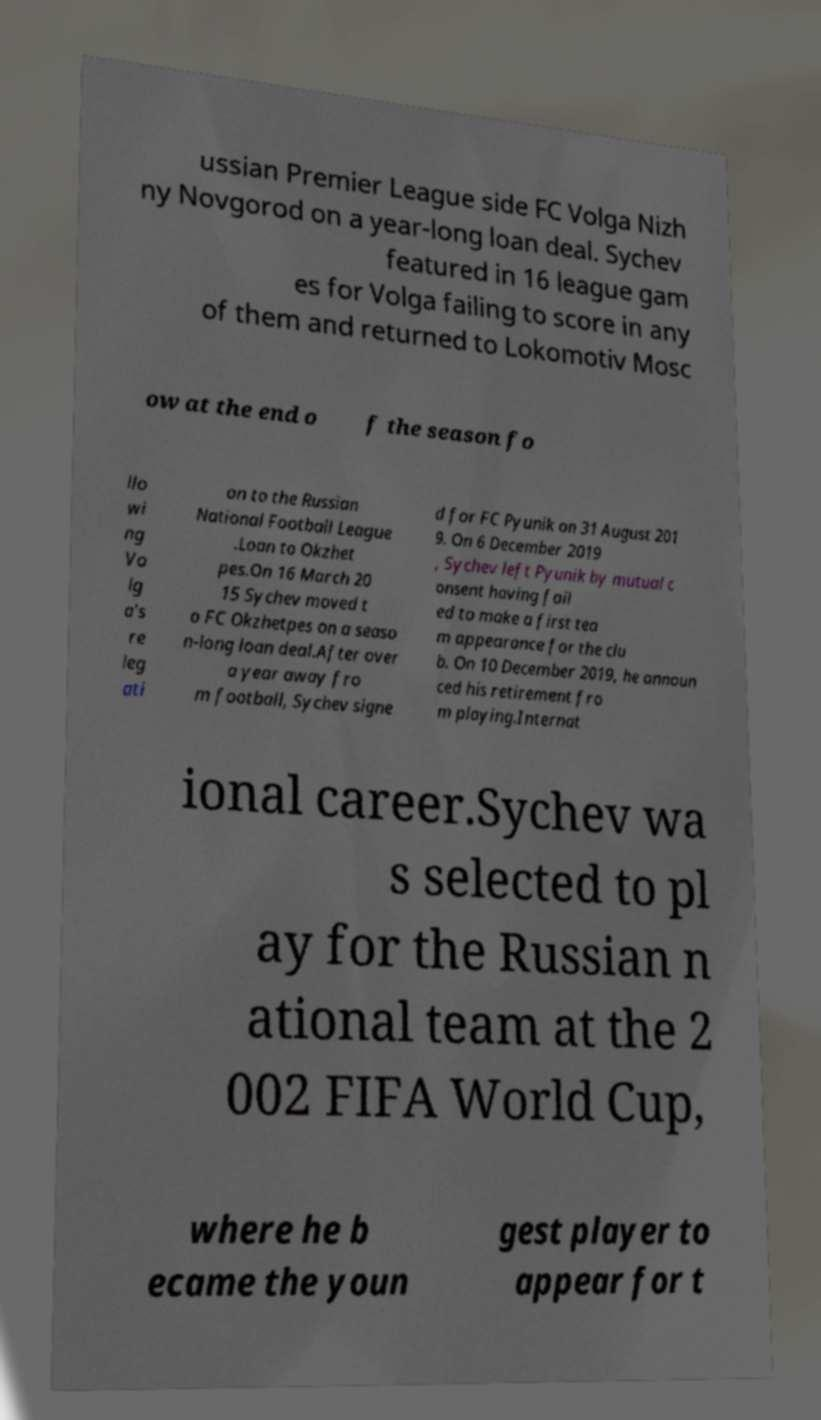Please read and relay the text visible in this image. What does it say? ussian Premier League side FC Volga Nizh ny Novgorod on a year-long loan deal. Sychev featured in 16 league gam es for Volga failing to score in any of them and returned to Lokomotiv Mosc ow at the end o f the season fo llo wi ng Vo lg a's re leg ati on to the Russian National Football League .Loan to Okzhet pes.On 16 March 20 15 Sychev moved t o FC Okzhetpes on a seaso n-long loan deal.After over a year away fro m football, Sychev signe d for FC Pyunik on 31 August 201 9. On 6 December 2019 , Sychev left Pyunik by mutual c onsent having fail ed to make a first tea m appearance for the clu b. On 10 December 2019, he announ ced his retirement fro m playing.Internat ional career.Sychev wa s selected to pl ay for the Russian n ational team at the 2 002 FIFA World Cup, where he b ecame the youn gest player to appear for t 